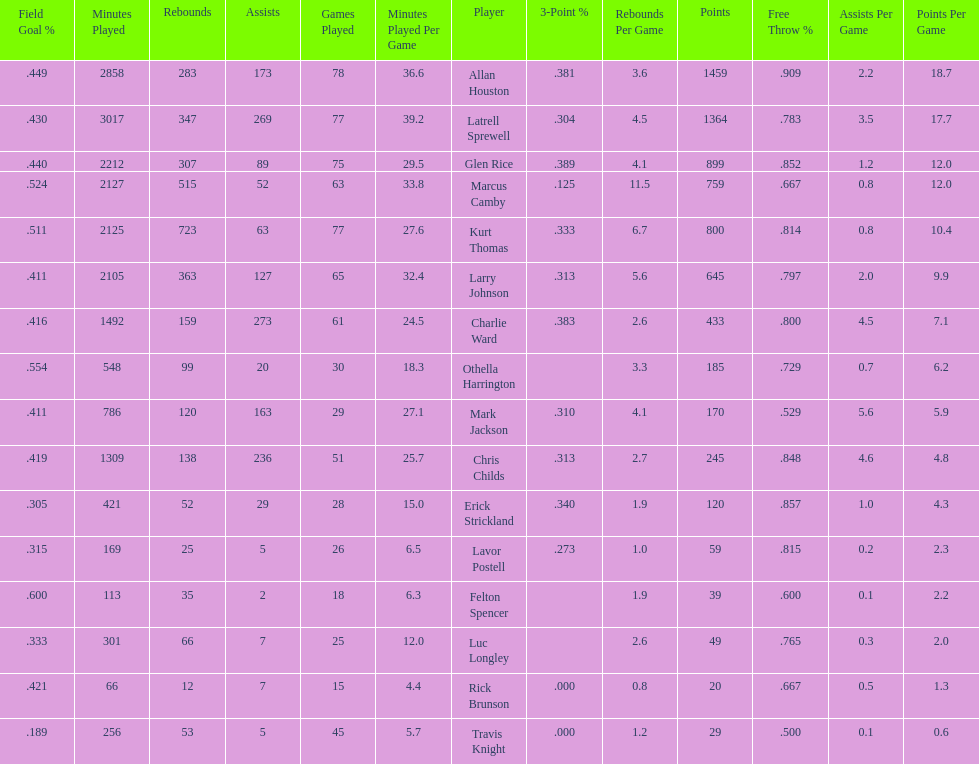Would you be able to parse every entry in this table? {'header': ['Field Goal\xa0%', 'Minutes Played', 'Rebounds', 'Assists', 'Games Played', 'Minutes Played Per Game', 'Player', '3-Point\xa0%', 'Rebounds Per Game', 'Points', 'Free Throw\xa0%', 'Assists Per Game', 'Points Per Game'], 'rows': [['.449', '2858', '283', '173', '78', '36.6', 'Allan Houston', '.381', '3.6', '1459', '.909', '2.2', '18.7'], ['.430', '3017', '347', '269', '77', '39.2', 'Latrell Sprewell', '.304', '4.5', '1364', '.783', '3.5', '17.7'], ['.440', '2212', '307', '89', '75', '29.5', 'Glen Rice', '.389', '4.1', '899', '.852', '1.2', '12.0'], ['.524', '2127', '515', '52', '63', '33.8', 'Marcus Camby', '.125', '11.5', '759', '.667', '0.8', '12.0'], ['.511', '2125', '723', '63', '77', '27.6', 'Kurt Thomas', '.333', '6.7', '800', '.814', '0.8', '10.4'], ['.411', '2105', '363', '127', '65', '32.4', 'Larry Johnson', '.313', '5.6', '645', '.797', '2.0', '9.9'], ['.416', '1492', '159', '273', '61', '24.5', 'Charlie Ward', '.383', '2.6', '433', '.800', '4.5', '7.1'], ['.554', '548', '99', '20', '30', '18.3', 'Othella Harrington', '', '3.3', '185', '.729', '0.7', '6.2'], ['.411', '786', '120', '163', '29', '27.1', 'Mark Jackson', '.310', '4.1', '170', '.529', '5.6', '5.9'], ['.419', '1309', '138', '236', '51', '25.7', 'Chris Childs', '.313', '2.7', '245', '.848', '4.6', '4.8'], ['.305', '421', '52', '29', '28', '15.0', 'Erick Strickland', '.340', '1.9', '120', '.857', '1.0', '4.3'], ['.315', '169', '25', '5', '26', '6.5', 'Lavor Postell', '.273', '1.0', '59', '.815', '0.2', '2.3'], ['.600', '113', '35', '2', '18', '6.3', 'Felton Spencer', '', '1.9', '39', '.600', '0.1', '2.2'], ['.333', '301', '66', '7', '25', '12.0', 'Luc Longley', '', '2.6', '49', '.765', '0.3', '2.0'], ['.421', '66', '12', '7', '15', '4.4', 'Rick Brunson', '.000', '0.8', '20', '.667', '0.5', '1.3'], ['.189', '256', '53', '5', '45', '5.7', 'Travis Knight', '.000', '1.2', '29', '.500', '0.1', '0.6']]} Number of players on the team. 16. 